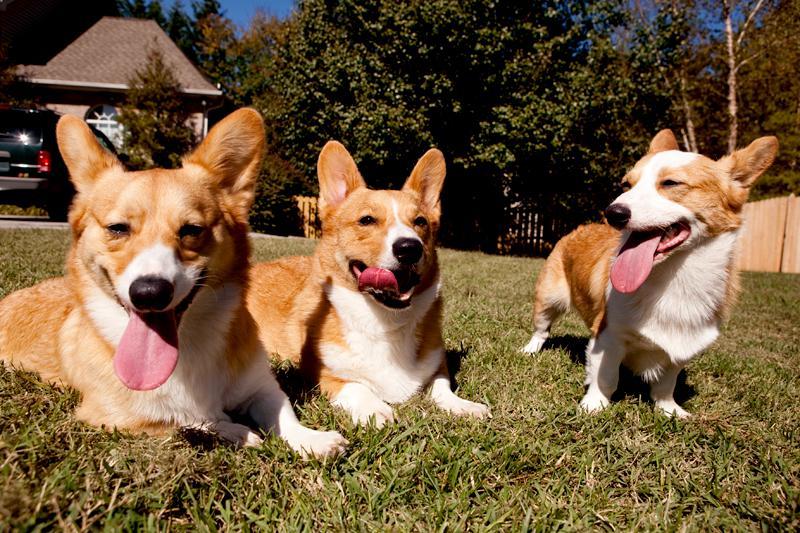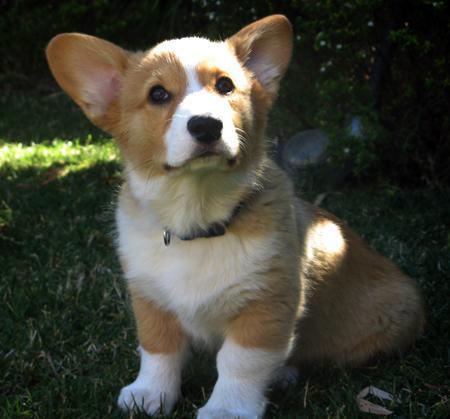The first image is the image on the left, the second image is the image on the right. Given the left and right images, does the statement "There are two small dogs wearing costumes" hold true? Answer yes or no. No. The first image is the image on the left, the second image is the image on the right. Analyze the images presented: Is the assertion "Corgis are dressing in costumes" valid? Answer yes or no. No. 